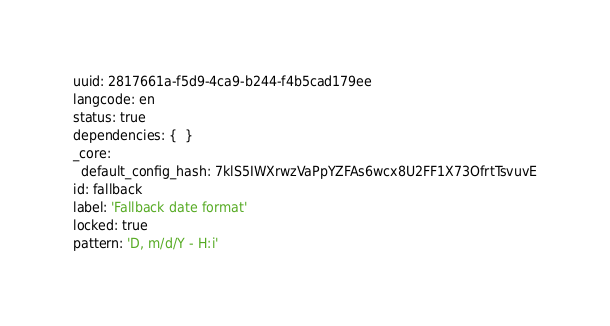<code> <loc_0><loc_0><loc_500><loc_500><_YAML_>uuid: 2817661a-f5d9-4ca9-b244-f4b5cad179ee
langcode: en
status: true
dependencies: {  }
_core:
  default_config_hash: 7klS5IWXrwzVaPpYZFAs6wcx8U2FF1X73OfrtTsvuvE
id: fallback
label: 'Fallback date format'
locked: true
pattern: 'D, m/d/Y - H:i'
</code> 